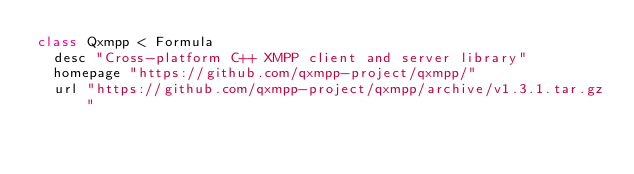Convert code to text. <code><loc_0><loc_0><loc_500><loc_500><_Ruby_>class Qxmpp < Formula
  desc "Cross-platform C++ XMPP client and server library"
  homepage "https://github.com/qxmpp-project/qxmpp/"
  url "https://github.com/qxmpp-project/qxmpp/archive/v1.3.1.tar.gz"</code> 